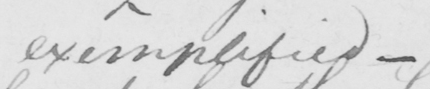Transcribe the text shown in this historical manuscript line. exemplified  _ 